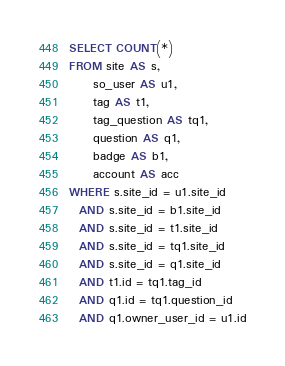Convert code to text. <code><loc_0><loc_0><loc_500><loc_500><_SQL_>SELECT COUNT(*)
FROM site AS s,
     so_user AS u1,
     tag AS t1,
     tag_question AS tq1,
     question AS q1,
     badge AS b1,
     account AS acc
WHERE s.site_id = u1.site_id
  AND s.site_id = b1.site_id
  AND s.site_id = t1.site_id
  AND s.site_id = tq1.site_id
  AND s.site_id = q1.site_id
  AND t1.id = tq1.tag_id
  AND q1.id = tq1.question_id
  AND q1.owner_user_id = u1.id</code> 